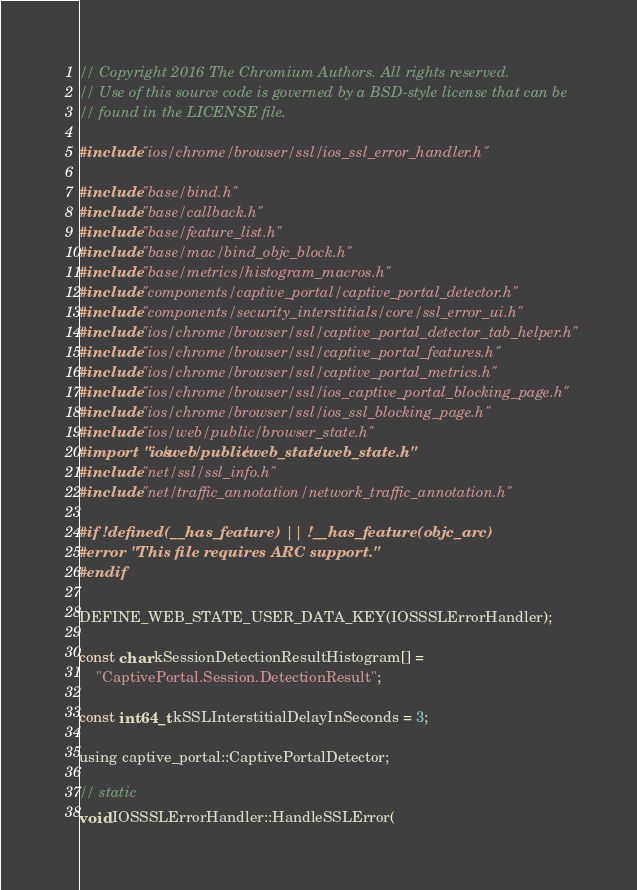Convert code to text. <code><loc_0><loc_0><loc_500><loc_500><_ObjectiveC_>// Copyright 2016 The Chromium Authors. All rights reserved.
// Use of this source code is governed by a BSD-style license that can be
// found in the LICENSE file.

#include "ios/chrome/browser/ssl/ios_ssl_error_handler.h"

#include "base/bind.h"
#include "base/callback.h"
#include "base/feature_list.h"
#include "base/mac/bind_objc_block.h"
#include "base/metrics/histogram_macros.h"
#include "components/captive_portal/captive_portal_detector.h"
#include "components/security_interstitials/core/ssl_error_ui.h"
#include "ios/chrome/browser/ssl/captive_portal_detector_tab_helper.h"
#include "ios/chrome/browser/ssl/captive_portal_features.h"
#include "ios/chrome/browser/ssl/captive_portal_metrics.h"
#include "ios/chrome/browser/ssl/ios_captive_portal_blocking_page.h"
#include "ios/chrome/browser/ssl/ios_ssl_blocking_page.h"
#include "ios/web/public/browser_state.h"
#import "ios/web/public/web_state/web_state.h"
#include "net/ssl/ssl_info.h"
#include "net/traffic_annotation/network_traffic_annotation.h"

#if !defined(__has_feature) || !__has_feature(objc_arc)
#error "This file requires ARC support."
#endif

DEFINE_WEB_STATE_USER_DATA_KEY(IOSSSLErrorHandler);

const char kSessionDetectionResultHistogram[] =
    "CaptivePortal.Session.DetectionResult";

const int64_t kSSLInterstitialDelayInSeconds = 3;

using captive_portal::CaptivePortalDetector;

// static
void IOSSSLErrorHandler::HandleSSLError(</code> 